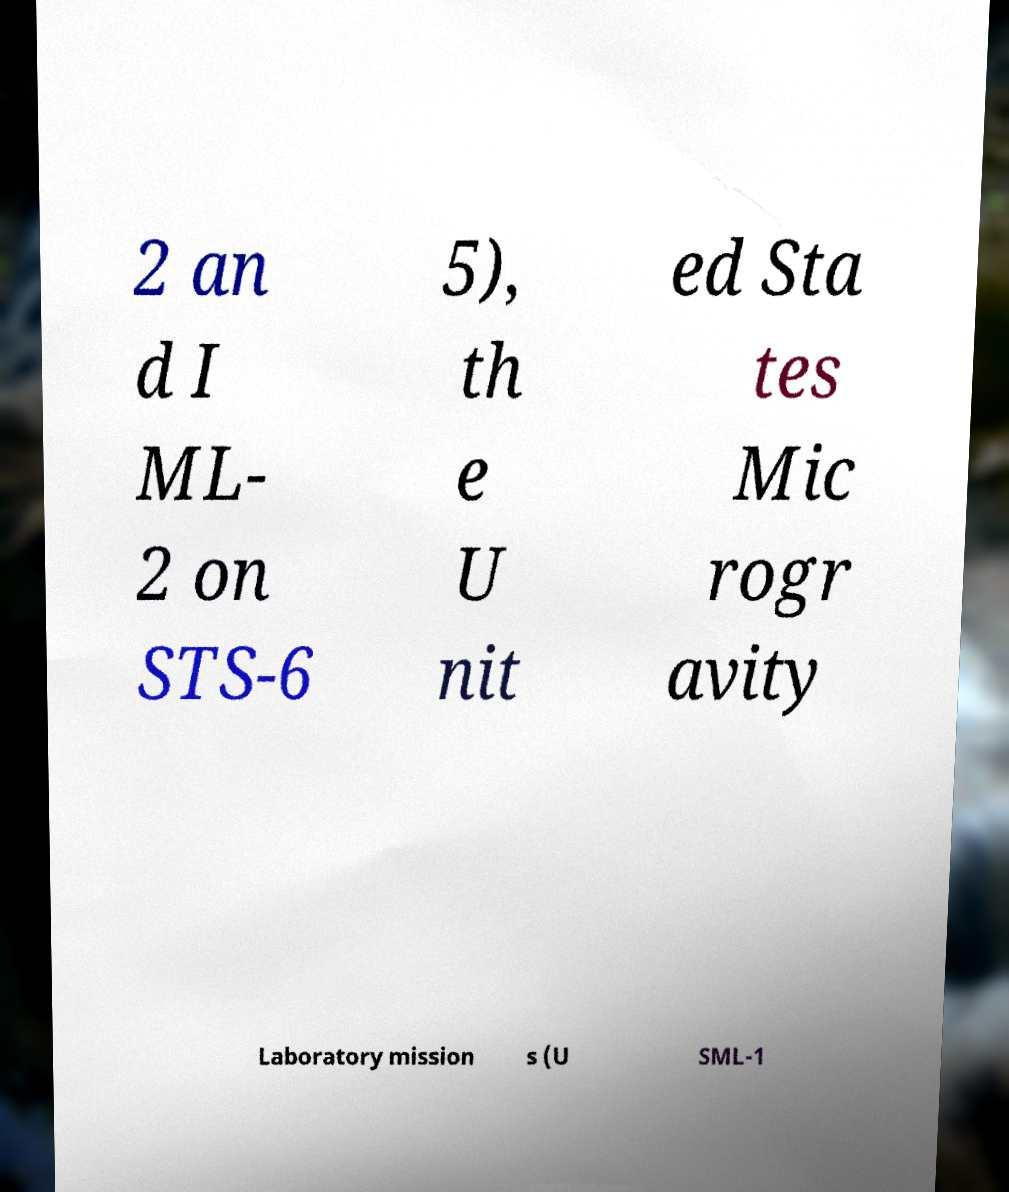Please identify and transcribe the text found in this image. 2 an d I ML- 2 on STS-6 5), th e U nit ed Sta tes Mic rogr avity Laboratory mission s (U SML-1 